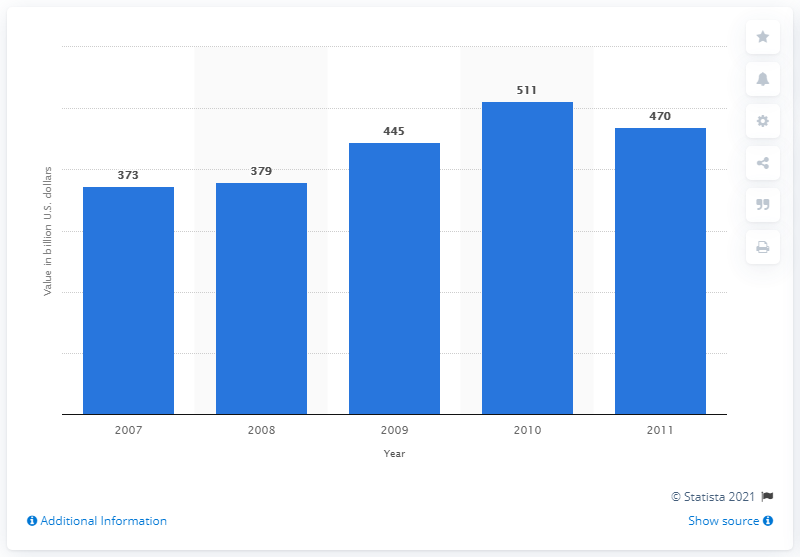Identify some key points in this picture. In 2011, the total value of distributed coupons in the United States was approximately 470 million dollars. In 2011, the total value of packaged foods was approximately $470 billion. The packaged foods available in 2007 were significantly different from those available in 2008, with a noticeable increase in the variety and quality of options available. 